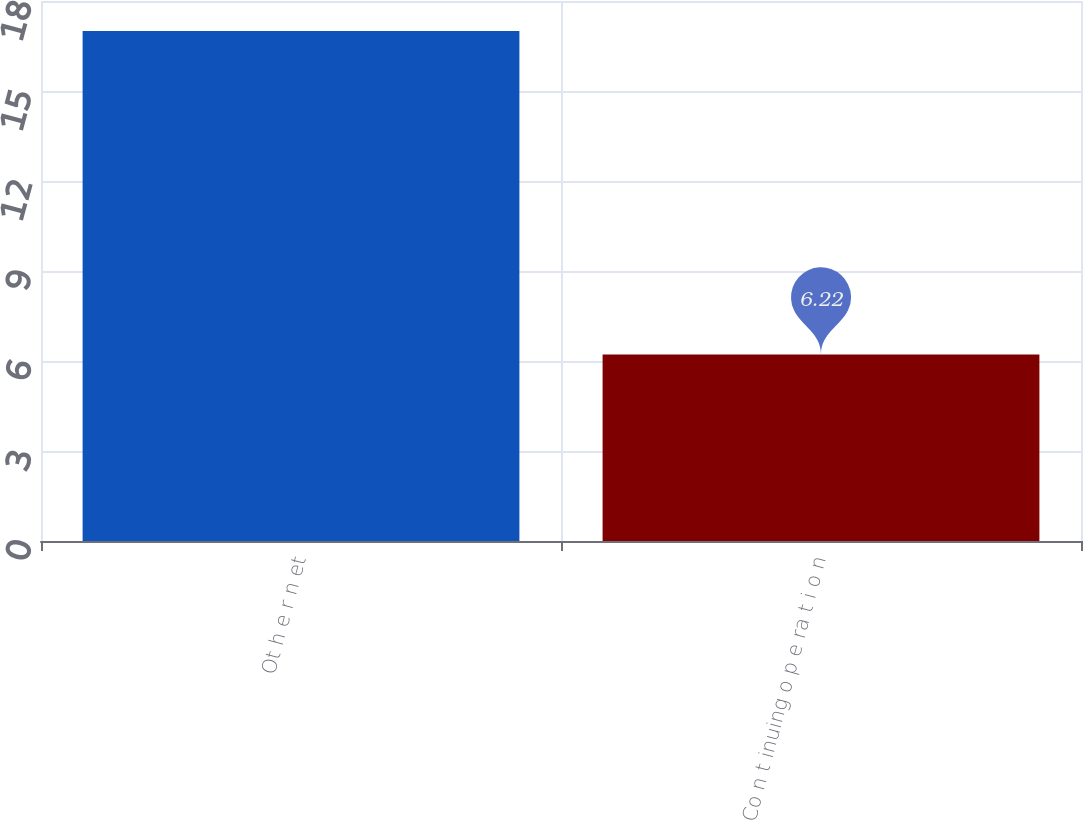Convert chart to OTSL. <chart><loc_0><loc_0><loc_500><loc_500><bar_chart><fcel>Ot h e r n et<fcel>Co n t inuing o p e ra t i o n<nl><fcel>17<fcel>6.22<nl></chart> 